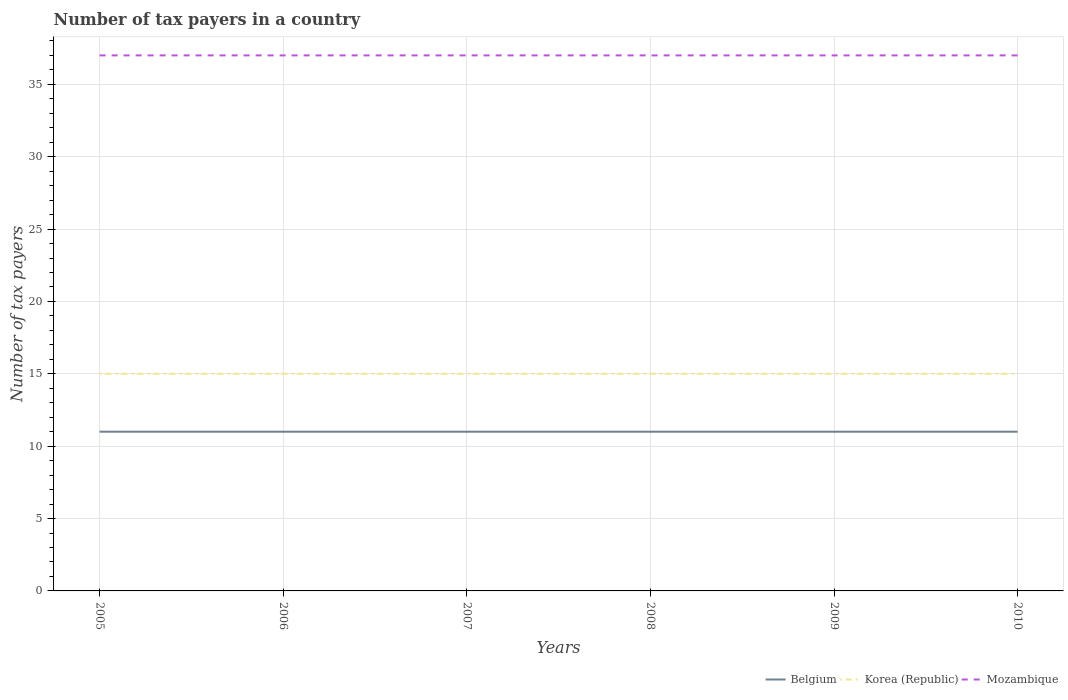How many different coloured lines are there?
Provide a short and direct response. 3. Does the line corresponding to Belgium intersect with the line corresponding to Korea (Republic)?
Offer a terse response. No. Is the number of lines equal to the number of legend labels?
Keep it short and to the point. Yes. Across all years, what is the maximum number of tax payers in in Mozambique?
Provide a succinct answer. 37. In which year was the number of tax payers in in Mozambique maximum?
Your answer should be very brief. 2005. What is the total number of tax payers in in Belgium in the graph?
Offer a terse response. 0. What is the difference between the highest and the second highest number of tax payers in in Mozambique?
Keep it short and to the point. 0. What is the difference between the highest and the lowest number of tax payers in in Belgium?
Ensure brevity in your answer.  0. Is the number of tax payers in in Belgium strictly greater than the number of tax payers in in Korea (Republic) over the years?
Give a very brief answer. Yes. How many lines are there?
Make the answer very short. 3. What is the difference between two consecutive major ticks on the Y-axis?
Your answer should be very brief. 5. Are the values on the major ticks of Y-axis written in scientific E-notation?
Offer a very short reply. No. Does the graph contain any zero values?
Your answer should be very brief. No. How many legend labels are there?
Ensure brevity in your answer.  3. What is the title of the graph?
Provide a short and direct response. Number of tax payers in a country. What is the label or title of the X-axis?
Your response must be concise. Years. What is the label or title of the Y-axis?
Your answer should be compact. Number of tax payers. What is the Number of tax payers of Korea (Republic) in 2005?
Give a very brief answer. 15. What is the Number of tax payers of Belgium in 2007?
Offer a terse response. 11. What is the Number of tax payers in Korea (Republic) in 2007?
Provide a short and direct response. 15. What is the Number of tax payers of Mozambique in 2009?
Provide a short and direct response. 37. What is the Number of tax payers in Belgium in 2010?
Make the answer very short. 11. Across all years, what is the maximum Number of tax payers of Belgium?
Provide a succinct answer. 11. Across all years, what is the maximum Number of tax payers of Korea (Republic)?
Offer a terse response. 15. Across all years, what is the minimum Number of tax payers of Belgium?
Your response must be concise. 11. Across all years, what is the minimum Number of tax payers in Korea (Republic)?
Ensure brevity in your answer.  15. What is the total Number of tax payers in Mozambique in the graph?
Ensure brevity in your answer.  222. What is the difference between the Number of tax payers of Mozambique in 2005 and that in 2009?
Ensure brevity in your answer.  0. What is the difference between the Number of tax payers of Belgium in 2005 and that in 2010?
Make the answer very short. 0. What is the difference between the Number of tax payers of Korea (Republic) in 2006 and that in 2007?
Keep it short and to the point. 0. What is the difference between the Number of tax payers in Mozambique in 2006 and that in 2008?
Offer a very short reply. 0. What is the difference between the Number of tax payers in Korea (Republic) in 2006 and that in 2009?
Offer a very short reply. 0. What is the difference between the Number of tax payers in Korea (Republic) in 2006 and that in 2010?
Provide a short and direct response. 0. What is the difference between the Number of tax payers in Korea (Republic) in 2007 and that in 2009?
Your response must be concise. 0. What is the difference between the Number of tax payers in Mozambique in 2007 and that in 2009?
Keep it short and to the point. 0. What is the difference between the Number of tax payers in Belgium in 2007 and that in 2010?
Your answer should be very brief. 0. What is the difference between the Number of tax payers of Korea (Republic) in 2007 and that in 2010?
Your answer should be compact. 0. What is the difference between the Number of tax payers in Mozambique in 2008 and that in 2009?
Your response must be concise. 0. What is the difference between the Number of tax payers of Belgium in 2008 and that in 2010?
Provide a succinct answer. 0. What is the difference between the Number of tax payers in Korea (Republic) in 2008 and that in 2010?
Give a very brief answer. 0. What is the difference between the Number of tax payers of Korea (Republic) in 2009 and that in 2010?
Provide a short and direct response. 0. What is the difference between the Number of tax payers of Belgium in 2005 and the Number of tax payers of Mozambique in 2006?
Make the answer very short. -26. What is the difference between the Number of tax payers of Korea (Republic) in 2005 and the Number of tax payers of Mozambique in 2006?
Your answer should be compact. -22. What is the difference between the Number of tax payers of Belgium in 2005 and the Number of tax payers of Korea (Republic) in 2007?
Offer a terse response. -4. What is the difference between the Number of tax payers in Belgium in 2005 and the Number of tax payers in Korea (Republic) in 2008?
Ensure brevity in your answer.  -4. What is the difference between the Number of tax payers in Belgium in 2005 and the Number of tax payers in Mozambique in 2008?
Your response must be concise. -26. What is the difference between the Number of tax payers of Belgium in 2005 and the Number of tax payers of Korea (Republic) in 2009?
Your answer should be very brief. -4. What is the difference between the Number of tax payers in Belgium in 2005 and the Number of tax payers in Mozambique in 2009?
Offer a very short reply. -26. What is the difference between the Number of tax payers in Korea (Republic) in 2005 and the Number of tax payers in Mozambique in 2009?
Make the answer very short. -22. What is the difference between the Number of tax payers in Belgium in 2005 and the Number of tax payers in Korea (Republic) in 2010?
Keep it short and to the point. -4. What is the difference between the Number of tax payers in Belgium in 2005 and the Number of tax payers in Mozambique in 2010?
Provide a short and direct response. -26. What is the difference between the Number of tax payers of Korea (Republic) in 2005 and the Number of tax payers of Mozambique in 2010?
Make the answer very short. -22. What is the difference between the Number of tax payers of Belgium in 2006 and the Number of tax payers of Mozambique in 2007?
Ensure brevity in your answer.  -26. What is the difference between the Number of tax payers of Belgium in 2006 and the Number of tax payers of Mozambique in 2008?
Provide a short and direct response. -26. What is the difference between the Number of tax payers in Korea (Republic) in 2006 and the Number of tax payers in Mozambique in 2008?
Provide a short and direct response. -22. What is the difference between the Number of tax payers of Korea (Republic) in 2006 and the Number of tax payers of Mozambique in 2009?
Your answer should be compact. -22. What is the difference between the Number of tax payers in Korea (Republic) in 2006 and the Number of tax payers in Mozambique in 2010?
Give a very brief answer. -22. What is the difference between the Number of tax payers in Belgium in 2007 and the Number of tax payers in Korea (Republic) in 2008?
Provide a short and direct response. -4. What is the difference between the Number of tax payers in Korea (Republic) in 2007 and the Number of tax payers in Mozambique in 2008?
Your answer should be very brief. -22. What is the difference between the Number of tax payers of Belgium in 2007 and the Number of tax payers of Korea (Republic) in 2009?
Keep it short and to the point. -4. What is the difference between the Number of tax payers of Korea (Republic) in 2007 and the Number of tax payers of Mozambique in 2009?
Your response must be concise. -22. What is the difference between the Number of tax payers of Belgium in 2007 and the Number of tax payers of Mozambique in 2010?
Your answer should be compact. -26. What is the difference between the Number of tax payers of Belgium in 2008 and the Number of tax payers of Korea (Republic) in 2009?
Your answer should be compact. -4. What is the difference between the Number of tax payers in Belgium in 2008 and the Number of tax payers in Mozambique in 2009?
Keep it short and to the point. -26. What is the difference between the Number of tax payers in Korea (Republic) in 2008 and the Number of tax payers in Mozambique in 2009?
Offer a very short reply. -22. What is the difference between the Number of tax payers in Belgium in 2008 and the Number of tax payers in Korea (Republic) in 2010?
Your response must be concise. -4. What is the difference between the Number of tax payers in Belgium in 2008 and the Number of tax payers in Mozambique in 2010?
Provide a succinct answer. -26. What is the difference between the Number of tax payers in Korea (Republic) in 2008 and the Number of tax payers in Mozambique in 2010?
Provide a succinct answer. -22. What is the difference between the Number of tax payers of Belgium in 2009 and the Number of tax payers of Korea (Republic) in 2010?
Your response must be concise. -4. What is the difference between the Number of tax payers in Belgium in 2009 and the Number of tax payers in Mozambique in 2010?
Offer a terse response. -26. What is the average Number of tax payers in Korea (Republic) per year?
Ensure brevity in your answer.  15. In the year 2005, what is the difference between the Number of tax payers in Belgium and Number of tax payers in Mozambique?
Offer a terse response. -26. In the year 2006, what is the difference between the Number of tax payers in Belgium and Number of tax payers in Korea (Republic)?
Give a very brief answer. -4. In the year 2006, what is the difference between the Number of tax payers of Belgium and Number of tax payers of Mozambique?
Ensure brevity in your answer.  -26. In the year 2007, what is the difference between the Number of tax payers in Belgium and Number of tax payers in Mozambique?
Provide a succinct answer. -26. In the year 2008, what is the difference between the Number of tax payers in Belgium and Number of tax payers in Korea (Republic)?
Your response must be concise. -4. In the year 2008, what is the difference between the Number of tax payers of Korea (Republic) and Number of tax payers of Mozambique?
Give a very brief answer. -22. In the year 2009, what is the difference between the Number of tax payers in Belgium and Number of tax payers in Korea (Republic)?
Ensure brevity in your answer.  -4. In the year 2009, what is the difference between the Number of tax payers of Korea (Republic) and Number of tax payers of Mozambique?
Your response must be concise. -22. In the year 2010, what is the difference between the Number of tax payers of Belgium and Number of tax payers of Korea (Republic)?
Keep it short and to the point. -4. In the year 2010, what is the difference between the Number of tax payers of Korea (Republic) and Number of tax payers of Mozambique?
Make the answer very short. -22. What is the ratio of the Number of tax payers in Belgium in 2005 to that in 2007?
Ensure brevity in your answer.  1. What is the ratio of the Number of tax payers in Korea (Republic) in 2005 to that in 2007?
Give a very brief answer. 1. What is the ratio of the Number of tax payers of Belgium in 2005 to that in 2008?
Your answer should be very brief. 1. What is the ratio of the Number of tax payers in Korea (Republic) in 2005 to that in 2008?
Your answer should be compact. 1. What is the ratio of the Number of tax payers in Mozambique in 2005 to that in 2008?
Offer a terse response. 1. What is the ratio of the Number of tax payers of Belgium in 2005 to that in 2009?
Provide a succinct answer. 1. What is the ratio of the Number of tax payers of Mozambique in 2005 to that in 2009?
Your answer should be compact. 1. What is the ratio of the Number of tax payers of Korea (Republic) in 2005 to that in 2010?
Provide a succinct answer. 1. What is the ratio of the Number of tax payers in Belgium in 2006 to that in 2008?
Your response must be concise. 1. What is the ratio of the Number of tax payers in Korea (Republic) in 2006 to that in 2008?
Provide a short and direct response. 1. What is the ratio of the Number of tax payers in Belgium in 2006 to that in 2009?
Give a very brief answer. 1. What is the ratio of the Number of tax payers of Mozambique in 2006 to that in 2009?
Offer a very short reply. 1. What is the ratio of the Number of tax payers in Belgium in 2006 to that in 2010?
Offer a very short reply. 1. What is the ratio of the Number of tax payers in Mozambique in 2006 to that in 2010?
Provide a succinct answer. 1. What is the ratio of the Number of tax payers of Belgium in 2007 to that in 2008?
Your answer should be very brief. 1. What is the ratio of the Number of tax payers of Mozambique in 2007 to that in 2008?
Your answer should be compact. 1. What is the ratio of the Number of tax payers of Belgium in 2007 to that in 2010?
Your answer should be compact. 1. What is the ratio of the Number of tax payers in Korea (Republic) in 2007 to that in 2010?
Offer a very short reply. 1. What is the ratio of the Number of tax payers of Korea (Republic) in 2008 to that in 2009?
Your answer should be very brief. 1. What is the ratio of the Number of tax payers of Mozambique in 2009 to that in 2010?
Offer a terse response. 1. What is the difference between the highest and the second highest Number of tax payers in Belgium?
Keep it short and to the point. 0. What is the difference between the highest and the second highest Number of tax payers of Korea (Republic)?
Keep it short and to the point. 0. What is the difference between the highest and the second highest Number of tax payers in Mozambique?
Provide a short and direct response. 0. What is the difference between the highest and the lowest Number of tax payers in Mozambique?
Keep it short and to the point. 0. 